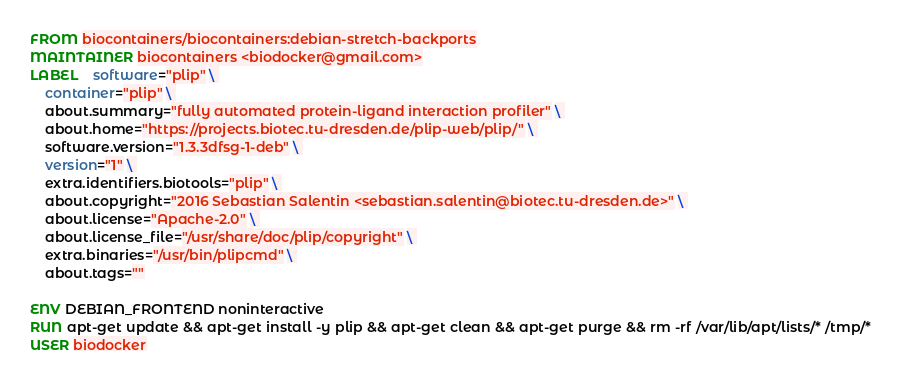<code> <loc_0><loc_0><loc_500><loc_500><_Dockerfile_>FROM biocontainers/biocontainers:debian-stretch-backports
MAINTAINER biocontainers <biodocker@gmail.com>
LABEL    software="plip" \ 
    container="plip" \ 
    about.summary="fully automated protein-ligand interaction profiler" \ 
    about.home="https://projects.biotec.tu-dresden.de/plip-web/plip/" \ 
    software.version="1.3.3dfsg-1-deb" \ 
    version="1" \ 
    extra.identifiers.biotools="plip" \ 
    about.copyright="2016 Sebastian Salentin <sebastian.salentin@biotec.tu-dresden.de>" \ 
    about.license="Apache-2.0" \ 
    about.license_file="/usr/share/doc/plip/copyright" \ 
    extra.binaries="/usr/bin/plipcmd" \ 
    about.tags=""

ENV DEBIAN_FRONTEND noninteractive
RUN apt-get update && apt-get install -y plip && apt-get clean && apt-get purge && rm -rf /var/lib/apt/lists/* /tmp/*
USER biodocker
</code> 